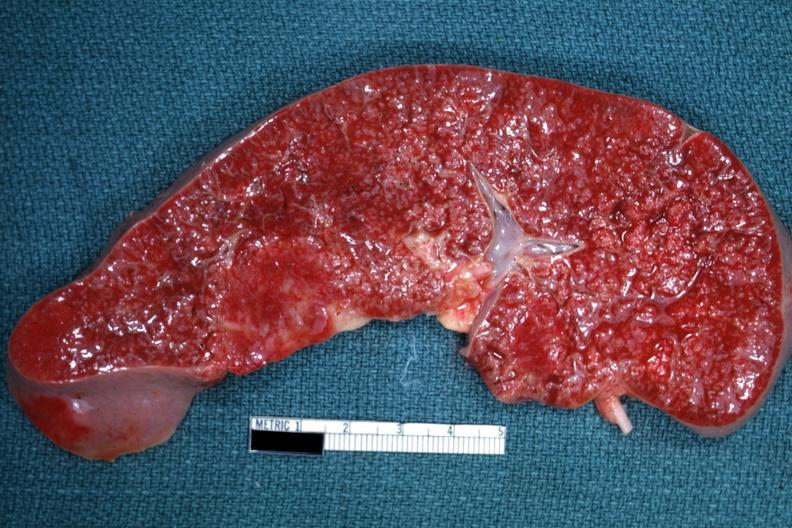where is this part in?
Answer the question using a single word or phrase. Spleen 